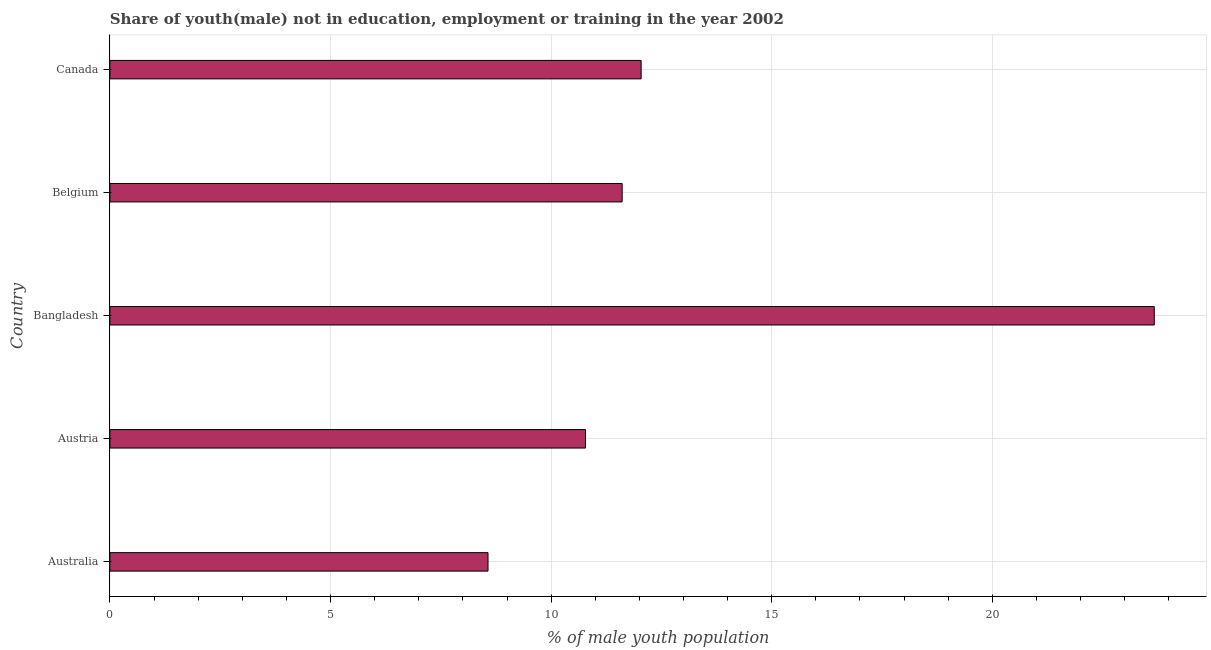Does the graph contain any zero values?
Keep it short and to the point. No. What is the title of the graph?
Your response must be concise. Share of youth(male) not in education, employment or training in the year 2002. What is the label or title of the X-axis?
Provide a succinct answer. % of male youth population. What is the unemployed male youth population in Austria?
Provide a succinct answer. 10.78. Across all countries, what is the maximum unemployed male youth population?
Ensure brevity in your answer.  23.67. Across all countries, what is the minimum unemployed male youth population?
Your answer should be compact. 8.57. In which country was the unemployed male youth population minimum?
Provide a succinct answer. Australia. What is the sum of the unemployed male youth population?
Ensure brevity in your answer.  66.67. What is the difference between the unemployed male youth population in Australia and Bangladesh?
Give a very brief answer. -15.1. What is the average unemployed male youth population per country?
Provide a short and direct response. 13.33. What is the median unemployed male youth population?
Give a very brief answer. 11.61. What is the ratio of the unemployed male youth population in Australia to that in Austria?
Offer a terse response. 0.8. Is the difference between the unemployed male youth population in Belgium and Canada greater than the difference between any two countries?
Make the answer very short. No. What is the difference between the highest and the second highest unemployed male youth population?
Provide a short and direct response. 11.63. Is the sum of the unemployed male youth population in Australia and Canada greater than the maximum unemployed male youth population across all countries?
Provide a succinct answer. No. In how many countries, is the unemployed male youth population greater than the average unemployed male youth population taken over all countries?
Give a very brief answer. 1. What is the difference between two consecutive major ticks on the X-axis?
Your answer should be very brief. 5. Are the values on the major ticks of X-axis written in scientific E-notation?
Ensure brevity in your answer.  No. What is the % of male youth population of Australia?
Your answer should be very brief. 8.57. What is the % of male youth population of Austria?
Ensure brevity in your answer.  10.78. What is the % of male youth population of Bangladesh?
Keep it short and to the point. 23.67. What is the % of male youth population in Belgium?
Make the answer very short. 11.61. What is the % of male youth population in Canada?
Offer a very short reply. 12.04. What is the difference between the % of male youth population in Australia and Austria?
Offer a terse response. -2.21. What is the difference between the % of male youth population in Australia and Bangladesh?
Ensure brevity in your answer.  -15.1. What is the difference between the % of male youth population in Australia and Belgium?
Make the answer very short. -3.04. What is the difference between the % of male youth population in Australia and Canada?
Offer a very short reply. -3.47. What is the difference between the % of male youth population in Austria and Bangladesh?
Your response must be concise. -12.89. What is the difference between the % of male youth population in Austria and Belgium?
Keep it short and to the point. -0.83. What is the difference between the % of male youth population in Austria and Canada?
Your answer should be very brief. -1.26. What is the difference between the % of male youth population in Bangladesh and Belgium?
Provide a succinct answer. 12.06. What is the difference between the % of male youth population in Bangladesh and Canada?
Offer a very short reply. 11.63. What is the difference between the % of male youth population in Belgium and Canada?
Offer a terse response. -0.43. What is the ratio of the % of male youth population in Australia to that in Austria?
Give a very brief answer. 0.8. What is the ratio of the % of male youth population in Australia to that in Bangladesh?
Make the answer very short. 0.36. What is the ratio of the % of male youth population in Australia to that in Belgium?
Provide a short and direct response. 0.74. What is the ratio of the % of male youth population in Australia to that in Canada?
Ensure brevity in your answer.  0.71. What is the ratio of the % of male youth population in Austria to that in Bangladesh?
Your answer should be very brief. 0.46. What is the ratio of the % of male youth population in Austria to that in Belgium?
Give a very brief answer. 0.93. What is the ratio of the % of male youth population in Austria to that in Canada?
Offer a very short reply. 0.9. What is the ratio of the % of male youth population in Bangladesh to that in Belgium?
Your answer should be very brief. 2.04. What is the ratio of the % of male youth population in Bangladesh to that in Canada?
Provide a succinct answer. 1.97. 